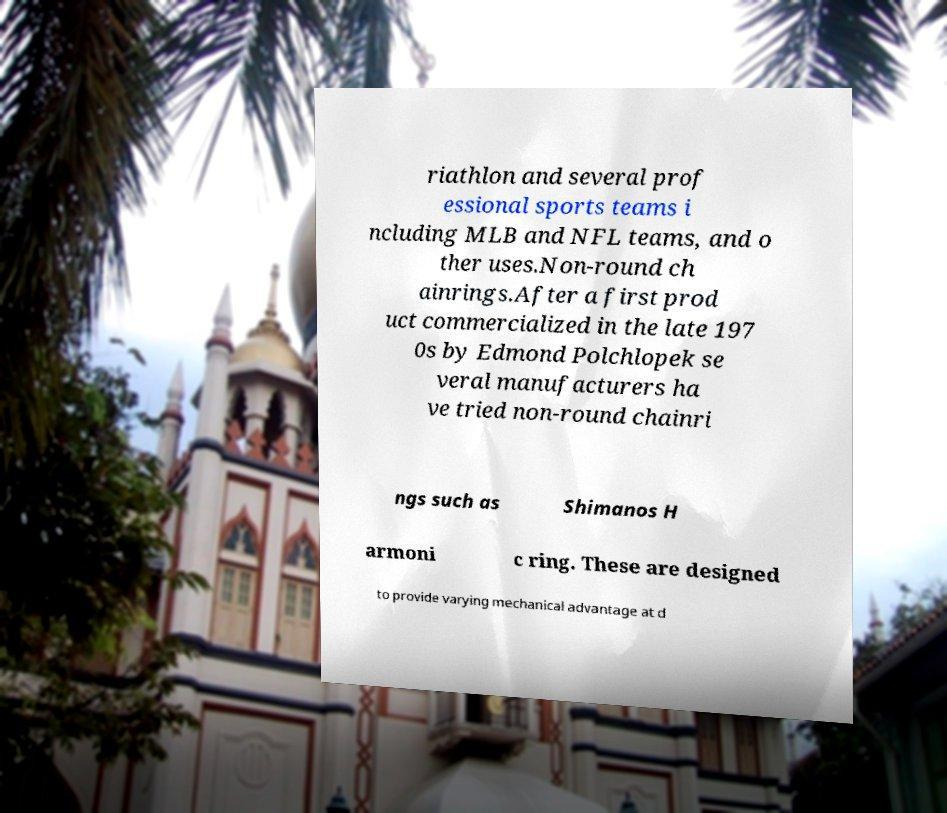Please read and relay the text visible in this image. What does it say? riathlon and several prof essional sports teams i ncluding MLB and NFL teams, and o ther uses.Non-round ch ainrings.After a first prod uct commercialized in the late 197 0s by Edmond Polchlopek se veral manufacturers ha ve tried non-round chainri ngs such as Shimanos H armoni c ring. These are designed to provide varying mechanical advantage at d 